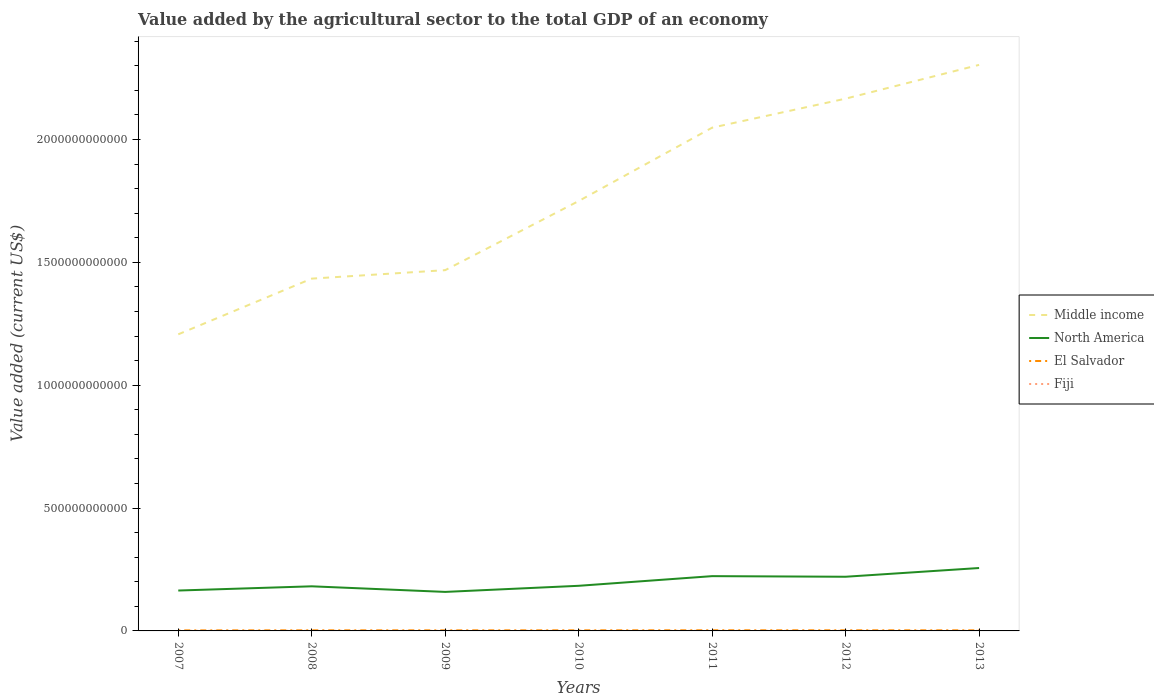Across all years, what is the maximum value added by the agricultural sector to the total GDP in North America?
Your answer should be compact. 1.59e+11. What is the total value added by the agricultural sector to the total GDP in Middle income in the graph?
Your answer should be compact. -8.70e+11. What is the difference between the highest and the second highest value added by the agricultural sector to the total GDP in Fiji?
Give a very brief answer. 1.34e+08. What is the difference between the highest and the lowest value added by the agricultural sector to the total GDP in North America?
Offer a terse response. 3. What is the difference between two consecutive major ticks on the Y-axis?
Provide a short and direct response. 5.00e+11. Are the values on the major ticks of Y-axis written in scientific E-notation?
Make the answer very short. No. Does the graph contain grids?
Give a very brief answer. No. Where does the legend appear in the graph?
Make the answer very short. Center right. How many legend labels are there?
Keep it short and to the point. 4. What is the title of the graph?
Provide a short and direct response. Value added by the agricultural sector to the total GDP of an economy. What is the label or title of the X-axis?
Provide a short and direct response. Years. What is the label or title of the Y-axis?
Offer a very short reply. Value added (current US$). What is the Value added (current US$) in Middle income in 2007?
Provide a succinct answer. 1.21e+12. What is the Value added (current US$) in North America in 2007?
Your answer should be compact. 1.64e+11. What is the Value added (current US$) in El Salvador in 2007?
Your answer should be very brief. 2.19e+09. What is the Value added (current US$) of Fiji in 2007?
Keep it short and to the point. 4.01e+08. What is the Value added (current US$) in Middle income in 2008?
Give a very brief answer. 1.43e+12. What is the Value added (current US$) of North America in 2008?
Offer a very short reply. 1.82e+11. What is the Value added (current US$) in El Salvador in 2008?
Your response must be concise. 2.46e+09. What is the Value added (current US$) in Fiji in 2008?
Make the answer very short. 3.77e+08. What is the Value added (current US$) in Middle income in 2009?
Provide a succinct answer. 1.47e+12. What is the Value added (current US$) of North America in 2009?
Your answer should be compact. 1.59e+11. What is the Value added (current US$) in El Salvador in 2009?
Make the answer very short. 2.37e+09. What is the Value added (current US$) in Fiji in 2009?
Keep it short and to the point. 2.90e+08. What is the Value added (current US$) in Middle income in 2010?
Your answer should be compact. 1.75e+12. What is the Value added (current US$) of North America in 2010?
Give a very brief answer. 1.84e+11. What is the Value added (current US$) of El Salvador in 2010?
Your response must be concise. 2.48e+09. What is the Value added (current US$) in Fiji in 2010?
Keep it short and to the point. 2.95e+08. What is the Value added (current US$) in Middle income in 2011?
Give a very brief answer. 2.05e+12. What is the Value added (current US$) in North America in 2011?
Offer a very short reply. 2.23e+11. What is the Value added (current US$) of El Salvador in 2011?
Provide a succinct answer. 2.65e+09. What is the Value added (current US$) in Fiji in 2011?
Give a very brief answer. 3.48e+08. What is the Value added (current US$) of Middle income in 2012?
Give a very brief answer. 2.17e+12. What is the Value added (current US$) in North America in 2012?
Your response must be concise. 2.21e+11. What is the Value added (current US$) of El Salvador in 2012?
Offer a terse response. 2.60e+09. What is the Value added (current US$) in Fiji in 2012?
Ensure brevity in your answer.  3.84e+08. What is the Value added (current US$) of Middle income in 2013?
Offer a terse response. 2.30e+12. What is the Value added (current US$) of North America in 2013?
Provide a short and direct response. 2.56e+11. What is the Value added (current US$) of El Salvador in 2013?
Keep it short and to the point. 2.45e+09. What is the Value added (current US$) of Fiji in 2013?
Make the answer very short. 4.24e+08. Across all years, what is the maximum Value added (current US$) in Middle income?
Provide a succinct answer. 2.30e+12. Across all years, what is the maximum Value added (current US$) of North America?
Offer a very short reply. 2.56e+11. Across all years, what is the maximum Value added (current US$) in El Salvador?
Offer a very short reply. 2.65e+09. Across all years, what is the maximum Value added (current US$) of Fiji?
Offer a terse response. 4.24e+08. Across all years, what is the minimum Value added (current US$) of Middle income?
Provide a short and direct response. 1.21e+12. Across all years, what is the minimum Value added (current US$) of North America?
Offer a very short reply. 1.59e+11. Across all years, what is the minimum Value added (current US$) in El Salvador?
Your answer should be very brief. 2.19e+09. Across all years, what is the minimum Value added (current US$) in Fiji?
Your response must be concise. 2.90e+08. What is the total Value added (current US$) in Middle income in the graph?
Your answer should be very brief. 1.24e+13. What is the total Value added (current US$) of North America in the graph?
Provide a succinct answer. 1.39e+12. What is the total Value added (current US$) of El Salvador in the graph?
Make the answer very short. 1.72e+1. What is the total Value added (current US$) of Fiji in the graph?
Your answer should be very brief. 2.52e+09. What is the difference between the Value added (current US$) in Middle income in 2007 and that in 2008?
Provide a succinct answer. -2.27e+11. What is the difference between the Value added (current US$) of North America in 2007 and that in 2008?
Provide a short and direct response. -1.72e+1. What is the difference between the Value added (current US$) in El Salvador in 2007 and that in 2008?
Ensure brevity in your answer.  -2.79e+08. What is the difference between the Value added (current US$) in Fiji in 2007 and that in 2008?
Offer a very short reply. 2.45e+07. What is the difference between the Value added (current US$) in Middle income in 2007 and that in 2009?
Keep it short and to the point. -2.61e+11. What is the difference between the Value added (current US$) of North America in 2007 and that in 2009?
Offer a terse response. 5.62e+09. What is the difference between the Value added (current US$) of El Salvador in 2007 and that in 2009?
Keep it short and to the point. -1.82e+08. What is the difference between the Value added (current US$) of Fiji in 2007 and that in 2009?
Provide a short and direct response. 1.12e+08. What is the difference between the Value added (current US$) of Middle income in 2007 and that in 2010?
Your answer should be very brief. -5.43e+11. What is the difference between the Value added (current US$) in North America in 2007 and that in 2010?
Ensure brevity in your answer.  -1.93e+1. What is the difference between the Value added (current US$) of El Salvador in 2007 and that in 2010?
Your response must be concise. -2.92e+08. What is the difference between the Value added (current US$) in Fiji in 2007 and that in 2010?
Offer a very short reply. 1.07e+08. What is the difference between the Value added (current US$) in Middle income in 2007 and that in 2011?
Provide a succinct answer. -8.41e+11. What is the difference between the Value added (current US$) of North America in 2007 and that in 2011?
Give a very brief answer. -5.85e+1. What is the difference between the Value added (current US$) of El Salvador in 2007 and that in 2011?
Make the answer very short. -4.66e+08. What is the difference between the Value added (current US$) in Fiji in 2007 and that in 2011?
Offer a very short reply. 5.35e+07. What is the difference between the Value added (current US$) in Middle income in 2007 and that in 2012?
Provide a short and direct response. -9.59e+11. What is the difference between the Value added (current US$) in North America in 2007 and that in 2012?
Keep it short and to the point. -5.61e+1. What is the difference between the Value added (current US$) of El Salvador in 2007 and that in 2012?
Make the answer very short. -4.12e+08. What is the difference between the Value added (current US$) in Fiji in 2007 and that in 2012?
Ensure brevity in your answer.  1.71e+07. What is the difference between the Value added (current US$) in Middle income in 2007 and that in 2013?
Offer a very short reply. -1.10e+12. What is the difference between the Value added (current US$) of North America in 2007 and that in 2013?
Your response must be concise. -9.17e+1. What is the difference between the Value added (current US$) of El Salvador in 2007 and that in 2013?
Your response must be concise. -2.63e+08. What is the difference between the Value added (current US$) in Fiji in 2007 and that in 2013?
Ensure brevity in your answer.  -2.23e+07. What is the difference between the Value added (current US$) in Middle income in 2008 and that in 2009?
Provide a short and direct response. -3.44e+1. What is the difference between the Value added (current US$) of North America in 2008 and that in 2009?
Ensure brevity in your answer.  2.28e+1. What is the difference between the Value added (current US$) of El Salvador in 2008 and that in 2009?
Your response must be concise. 9.73e+07. What is the difference between the Value added (current US$) in Fiji in 2008 and that in 2009?
Ensure brevity in your answer.  8.73e+07. What is the difference between the Value added (current US$) in Middle income in 2008 and that in 2010?
Provide a short and direct response. -3.16e+11. What is the difference between the Value added (current US$) of North America in 2008 and that in 2010?
Provide a succinct answer. -2.08e+09. What is the difference between the Value added (current US$) of El Salvador in 2008 and that in 2010?
Give a very brief answer. -1.29e+07. What is the difference between the Value added (current US$) in Fiji in 2008 and that in 2010?
Provide a succinct answer. 8.23e+07. What is the difference between the Value added (current US$) of Middle income in 2008 and that in 2011?
Give a very brief answer. -6.14e+11. What is the difference between the Value added (current US$) in North America in 2008 and that in 2011?
Your answer should be compact. -4.14e+1. What is the difference between the Value added (current US$) in El Salvador in 2008 and that in 2011?
Offer a terse response. -1.86e+08. What is the difference between the Value added (current US$) in Fiji in 2008 and that in 2011?
Offer a very short reply. 2.90e+07. What is the difference between the Value added (current US$) of Middle income in 2008 and that in 2012?
Keep it short and to the point. -7.32e+11. What is the difference between the Value added (current US$) in North America in 2008 and that in 2012?
Your response must be concise. -3.89e+1. What is the difference between the Value added (current US$) of El Salvador in 2008 and that in 2012?
Ensure brevity in your answer.  -1.32e+08. What is the difference between the Value added (current US$) of Fiji in 2008 and that in 2012?
Give a very brief answer. -7.43e+06. What is the difference between the Value added (current US$) of Middle income in 2008 and that in 2013?
Keep it short and to the point. -8.70e+11. What is the difference between the Value added (current US$) of North America in 2008 and that in 2013?
Keep it short and to the point. -7.45e+1. What is the difference between the Value added (current US$) of El Salvador in 2008 and that in 2013?
Ensure brevity in your answer.  1.62e+07. What is the difference between the Value added (current US$) in Fiji in 2008 and that in 2013?
Give a very brief answer. -4.69e+07. What is the difference between the Value added (current US$) of Middle income in 2009 and that in 2010?
Keep it short and to the point. -2.81e+11. What is the difference between the Value added (current US$) in North America in 2009 and that in 2010?
Offer a very short reply. -2.49e+1. What is the difference between the Value added (current US$) in El Salvador in 2009 and that in 2010?
Provide a short and direct response. -1.10e+08. What is the difference between the Value added (current US$) of Fiji in 2009 and that in 2010?
Offer a very short reply. -5.04e+06. What is the difference between the Value added (current US$) in Middle income in 2009 and that in 2011?
Make the answer very short. -5.80e+11. What is the difference between the Value added (current US$) in North America in 2009 and that in 2011?
Offer a terse response. -6.42e+1. What is the difference between the Value added (current US$) in El Salvador in 2009 and that in 2011?
Offer a very short reply. -2.84e+08. What is the difference between the Value added (current US$) of Fiji in 2009 and that in 2011?
Provide a succinct answer. -5.83e+07. What is the difference between the Value added (current US$) of Middle income in 2009 and that in 2012?
Offer a terse response. -6.98e+11. What is the difference between the Value added (current US$) in North America in 2009 and that in 2012?
Keep it short and to the point. -6.17e+1. What is the difference between the Value added (current US$) in El Salvador in 2009 and that in 2012?
Ensure brevity in your answer.  -2.30e+08. What is the difference between the Value added (current US$) of Fiji in 2009 and that in 2012?
Keep it short and to the point. -9.47e+07. What is the difference between the Value added (current US$) in Middle income in 2009 and that in 2013?
Your answer should be very brief. -8.36e+11. What is the difference between the Value added (current US$) of North America in 2009 and that in 2013?
Give a very brief answer. -9.73e+1. What is the difference between the Value added (current US$) in El Salvador in 2009 and that in 2013?
Make the answer very short. -8.11e+07. What is the difference between the Value added (current US$) in Fiji in 2009 and that in 2013?
Your answer should be compact. -1.34e+08. What is the difference between the Value added (current US$) in Middle income in 2010 and that in 2011?
Provide a short and direct response. -2.99e+11. What is the difference between the Value added (current US$) of North America in 2010 and that in 2011?
Ensure brevity in your answer.  -3.93e+1. What is the difference between the Value added (current US$) of El Salvador in 2010 and that in 2011?
Give a very brief answer. -1.74e+08. What is the difference between the Value added (current US$) of Fiji in 2010 and that in 2011?
Provide a short and direct response. -5.33e+07. What is the difference between the Value added (current US$) of Middle income in 2010 and that in 2012?
Ensure brevity in your answer.  -4.17e+11. What is the difference between the Value added (current US$) of North America in 2010 and that in 2012?
Your answer should be very brief. -3.69e+1. What is the difference between the Value added (current US$) in El Salvador in 2010 and that in 2012?
Give a very brief answer. -1.20e+08. What is the difference between the Value added (current US$) of Fiji in 2010 and that in 2012?
Offer a terse response. -8.97e+07. What is the difference between the Value added (current US$) of Middle income in 2010 and that in 2013?
Keep it short and to the point. -5.54e+11. What is the difference between the Value added (current US$) in North America in 2010 and that in 2013?
Ensure brevity in your answer.  -7.24e+1. What is the difference between the Value added (current US$) in El Salvador in 2010 and that in 2013?
Keep it short and to the point. 2.91e+07. What is the difference between the Value added (current US$) in Fiji in 2010 and that in 2013?
Your answer should be very brief. -1.29e+08. What is the difference between the Value added (current US$) in Middle income in 2011 and that in 2012?
Keep it short and to the point. -1.18e+11. What is the difference between the Value added (current US$) of North America in 2011 and that in 2012?
Provide a succinct answer. 2.44e+09. What is the difference between the Value added (current US$) in El Salvador in 2011 and that in 2012?
Give a very brief answer. 5.40e+07. What is the difference between the Value added (current US$) in Fiji in 2011 and that in 2012?
Give a very brief answer. -3.64e+07. What is the difference between the Value added (current US$) of Middle income in 2011 and that in 2013?
Offer a very short reply. -2.56e+11. What is the difference between the Value added (current US$) in North America in 2011 and that in 2013?
Provide a short and direct response. -3.31e+1. What is the difference between the Value added (current US$) in El Salvador in 2011 and that in 2013?
Provide a succinct answer. 2.03e+08. What is the difference between the Value added (current US$) of Fiji in 2011 and that in 2013?
Make the answer very short. -7.58e+07. What is the difference between the Value added (current US$) of Middle income in 2012 and that in 2013?
Your answer should be compact. -1.37e+11. What is the difference between the Value added (current US$) in North America in 2012 and that in 2013?
Ensure brevity in your answer.  -3.55e+1. What is the difference between the Value added (current US$) of El Salvador in 2012 and that in 2013?
Offer a very short reply. 1.49e+08. What is the difference between the Value added (current US$) in Fiji in 2012 and that in 2013?
Offer a very short reply. -3.94e+07. What is the difference between the Value added (current US$) of Middle income in 2007 and the Value added (current US$) of North America in 2008?
Your answer should be compact. 1.03e+12. What is the difference between the Value added (current US$) in Middle income in 2007 and the Value added (current US$) in El Salvador in 2008?
Provide a short and direct response. 1.20e+12. What is the difference between the Value added (current US$) in Middle income in 2007 and the Value added (current US$) in Fiji in 2008?
Your answer should be compact. 1.21e+12. What is the difference between the Value added (current US$) in North America in 2007 and the Value added (current US$) in El Salvador in 2008?
Provide a short and direct response. 1.62e+11. What is the difference between the Value added (current US$) of North America in 2007 and the Value added (current US$) of Fiji in 2008?
Offer a terse response. 1.64e+11. What is the difference between the Value added (current US$) of El Salvador in 2007 and the Value added (current US$) of Fiji in 2008?
Keep it short and to the point. 1.81e+09. What is the difference between the Value added (current US$) of Middle income in 2007 and the Value added (current US$) of North America in 2009?
Make the answer very short. 1.05e+12. What is the difference between the Value added (current US$) of Middle income in 2007 and the Value added (current US$) of El Salvador in 2009?
Provide a short and direct response. 1.20e+12. What is the difference between the Value added (current US$) of Middle income in 2007 and the Value added (current US$) of Fiji in 2009?
Provide a succinct answer. 1.21e+12. What is the difference between the Value added (current US$) of North America in 2007 and the Value added (current US$) of El Salvador in 2009?
Your response must be concise. 1.62e+11. What is the difference between the Value added (current US$) in North America in 2007 and the Value added (current US$) in Fiji in 2009?
Your answer should be compact. 1.64e+11. What is the difference between the Value added (current US$) of El Salvador in 2007 and the Value added (current US$) of Fiji in 2009?
Make the answer very short. 1.90e+09. What is the difference between the Value added (current US$) of Middle income in 2007 and the Value added (current US$) of North America in 2010?
Give a very brief answer. 1.02e+12. What is the difference between the Value added (current US$) in Middle income in 2007 and the Value added (current US$) in El Salvador in 2010?
Your answer should be very brief. 1.20e+12. What is the difference between the Value added (current US$) in Middle income in 2007 and the Value added (current US$) in Fiji in 2010?
Provide a short and direct response. 1.21e+12. What is the difference between the Value added (current US$) of North America in 2007 and the Value added (current US$) of El Salvador in 2010?
Give a very brief answer. 1.62e+11. What is the difference between the Value added (current US$) of North America in 2007 and the Value added (current US$) of Fiji in 2010?
Offer a very short reply. 1.64e+11. What is the difference between the Value added (current US$) of El Salvador in 2007 and the Value added (current US$) of Fiji in 2010?
Offer a terse response. 1.89e+09. What is the difference between the Value added (current US$) of Middle income in 2007 and the Value added (current US$) of North America in 2011?
Your answer should be compact. 9.84e+11. What is the difference between the Value added (current US$) of Middle income in 2007 and the Value added (current US$) of El Salvador in 2011?
Keep it short and to the point. 1.20e+12. What is the difference between the Value added (current US$) of Middle income in 2007 and the Value added (current US$) of Fiji in 2011?
Make the answer very short. 1.21e+12. What is the difference between the Value added (current US$) in North America in 2007 and the Value added (current US$) in El Salvador in 2011?
Your answer should be compact. 1.62e+11. What is the difference between the Value added (current US$) of North America in 2007 and the Value added (current US$) of Fiji in 2011?
Keep it short and to the point. 1.64e+11. What is the difference between the Value added (current US$) in El Salvador in 2007 and the Value added (current US$) in Fiji in 2011?
Offer a terse response. 1.84e+09. What is the difference between the Value added (current US$) of Middle income in 2007 and the Value added (current US$) of North America in 2012?
Your answer should be very brief. 9.87e+11. What is the difference between the Value added (current US$) in Middle income in 2007 and the Value added (current US$) in El Salvador in 2012?
Give a very brief answer. 1.20e+12. What is the difference between the Value added (current US$) in Middle income in 2007 and the Value added (current US$) in Fiji in 2012?
Make the answer very short. 1.21e+12. What is the difference between the Value added (current US$) in North America in 2007 and the Value added (current US$) in El Salvador in 2012?
Offer a very short reply. 1.62e+11. What is the difference between the Value added (current US$) in North America in 2007 and the Value added (current US$) in Fiji in 2012?
Offer a very short reply. 1.64e+11. What is the difference between the Value added (current US$) of El Salvador in 2007 and the Value added (current US$) of Fiji in 2012?
Give a very brief answer. 1.80e+09. What is the difference between the Value added (current US$) in Middle income in 2007 and the Value added (current US$) in North America in 2013?
Offer a terse response. 9.51e+11. What is the difference between the Value added (current US$) in Middle income in 2007 and the Value added (current US$) in El Salvador in 2013?
Offer a terse response. 1.20e+12. What is the difference between the Value added (current US$) of Middle income in 2007 and the Value added (current US$) of Fiji in 2013?
Your answer should be compact. 1.21e+12. What is the difference between the Value added (current US$) of North America in 2007 and the Value added (current US$) of El Salvador in 2013?
Offer a terse response. 1.62e+11. What is the difference between the Value added (current US$) of North America in 2007 and the Value added (current US$) of Fiji in 2013?
Provide a short and direct response. 1.64e+11. What is the difference between the Value added (current US$) of El Salvador in 2007 and the Value added (current US$) of Fiji in 2013?
Offer a terse response. 1.76e+09. What is the difference between the Value added (current US$) in Middle income in 2008 and the Value added (current US$) in North America in 2009?
Offer a very short reply. 1.28e+12. What is the difference between the Value added (current US$) of Middle income in 2008 and the Value added (current US$) of El Salvador in 2009?
Provide a short and direct response. 1.43e+12. What is the difference between the Value added (current US$) of Middle income in 2008 and the Value added (current US$) of Fiji in 2009?
Offer a terse response. 1.43e+12. What is the difference between the Value added (current US$) of North America in 2008 and the Value added (current US$) of El Salvador in 2009?
Offer a very short reply. 1.79e+11. What is the difference between the Value added (current US$) in North America in 2008 and the Value added (current US$) in Fiji in 2009?
Your answer should be compact. 1.81e+11. What is the difference between the Value added (current US$) of El Salvador in 2008 and the Value added (current US$) of Fiji in 2009?
Give a very brief answer. 2.18e+09. What is the difference between the Value added (current US$) in Middle income in 2008 and the Value added (current US$) in North America in 2010?
Provide a short and direct response. 1.25e+12. What is the difference between the Value added (current US$) in Middle income in 2008 and the Value added (current US$) in El Salvador in 2010?
Give a very brief answer. 1.43e+12. What is the difference between the Value added (current US$) of Middle income in 2008 and the Value added (current US$) of Fiji in 2010?
Offer a terse response. 1.43e+12. What is the difference between the Value added (current US$) of North America in 2008 and the Value added (current US$) of El Salvador in 2010?
Your response must be concise. 1.79e+11. What is the difference between the Value added (current US$) of North America in 2008 and the Value added (current US$) of Fiji in 2010?
Provide a succinct answer. 1.81e+11. What is the difference between the Value added (current US$) in El Salvador in 2008 and the Value added (current US$) in Fiji in 2010?
Your answer should be compact. 2.17e+09. What is the difference between the Value added (current US$) in Middle income in 2008 and the Value added (current US$) in North America in 2011?
Ensure brevity in your answer.  1.21e+12. What is the difference between the Value added (current US$) in Middle income in 2008 and the Value added (current US$) in El Salvador in 2011?
Make the answer very short. 1.43e+12. What is the difference between the Value added (current US$) in Middle income in 2008 and the Value added (current US$) in Fiji in 2011?
Your answer should be compact. 1.43e+12. What is the difference between the Value added (current US$) in North America in 2008 and the Value added (current US$) in El Salvador in 2011?
Keep it short and to the point. 1.79e+11. What is the difference between the Value added (current US$) in North America in 2008 and the Value added (current US$) in Fiji in 2011?
Provide a succinct answer. 1.81e+11. What is the difference between the Value added (current US$) of El Salvador in 2008 and the Value added (current US$) of Fiji in 2011?
Give a very brief answer. 2.12e+09. What is the difference between the Value added (current US$) of Middle income in 2008 and the Value added (current US$) of North America in 2012?
Ensure brevity in your answer.  1.21e+12. What is the difference between the Value added (current US$) of Middle income in 2008 and the Value added (current US$) of El Salvador in 2012?
Provide a succinct answer. 1.43e+12. What is the difference between the Value added (current US$) of Middle income in 2008 and the Value added (current US$) of Fiji in 2012?
Provide a succinct answer. 1.43e+12. What is the difference between the Value added (current US$) in North America in 2008 and the Value added (current US$) in El Salvador in 2012?
Give a very brief answer. 1.79e+11. What is the difference between the Value added (current US$) in North America in 2008 and the Value added (current US$) in Fiji in 2012?
Offer a terse response. 1.81e+11. What is the difference between the Value added (current US$) in El Salvador in 2008 and the Value added (current US$) in Fiji in 2012?
Keep it short and to the point. 2.08e+09. What is the difference between the Value added (current US$) in Middle income in 2008 and the Value added (current US$) in North America in 2013?
Offer a terse response. 1.18e+12. What is the difference between the Value added (current US$) in Middle income in 2008 and the Value added (current US$) in El Salvador in 2013?
Provide a succinct answer. 1.43e+12. What is the difference between the Value added (current US$) in Middle income in 2008 and the Value added (current US$) in Fiji in 2013?
Provide a succinct answer. 1.43e+12. What is the difference between the Value added (current US$) in North America in 2008 and the Value added (current US$) in El Salvador in 2013?
Your answer should be very brief. 1.79e+11. What is the difference between the Value added (current US$) of North America in 2008 and the Value added (current US$) of Fiji in 2013?
Your answer should be very brief. 1.81e+11. What is the difference between the Value added (current US$) of El Salvador in 2008 and the Value added (current US$) of Fiji in 2013?
Keep it short and to the point. 2.04e+09. What is the difference between the Value added (current US$) of Middle income in 2009 and the Value added (current US$) of North America in 2010?
Provide a succinct answer. 1.28e+12. What is the difference between the Value added (current US$) of Middle income in 2009 and the Value added (current US$) of El Salvador in 2010?
Provide a succinct answer. 1.47e+12. What is the difference between the Value added (current US$) of Middle income in 2009 and the Value added (current US$) of Fiji in 2010?
Provide a succinct answer. 1.47e+12. What is the difference between the Value added (current US$) of North America in 2009 and the Value added (current US$) of El Salvador in 2010?
Offer a terse response. 1.56e+11. What is the difference between the Value added (current US$) of North America in 2009 and the Value added (current US$) of Fiji in 2010?
Ensure brevity in your answer.  1.58e+11. What is the difference between the Value added (current US$) in El Salvador in 2009 and the Value added (current US$) in Fiji in 2010?
Offer a terse response. 2.07e+09. What is the difference between the Value added (current US$) of Middle income in 2009 and the Value added (current US$) of North America in 2011?
Give a very brief answer. 1.25e+12. What is the difference between the Value added (current US$) in Middle income in 2009 and the Value added (current US$) in El Salvador in 2011?
Provide a succinct answer. 1.47e+12. What is the difference between the Value added (current US$) in Middle income in 2009 and the Value added (current US$) in Fiji in 2011?
Your response must be concise. 1.47e+12. What is the difference between the Value added (current US$) in North America in 2009 and the Value added (current US$) in El Salvador in 2011?
Make the answer very short. 1.56e+11. What is the difference between the Value added (current US$) in North America in 2009 and the Value added (current US$) in Fiji in 2011?
Your response must be concise. 1.58e+11. What is the difference between the Value added (current US$) of El Salvador in 2009 and the Value added (current US$) of Fiji in 2011?
Offer a terse response. 2.02e+09. What is the difference between the Value added (current US$) in Middle income in 2009 and the Value added (current US$) in North America in 2012?
Offer a terse response. 1.25e+12. What is the difference between the Value added (current US$) in Middle income in 2009 and the Value added (current US$) in El Salvador in 2012?
Make the answer very short. 1.47e+12. What is the difference between the Value added (current US$) in Middle income in 2009 and the Value added (current US$) in Fiji in 2012?
Offer a terse response. 1.47e+12. What is the difference between the Value added (current US$) in North America in 2009 and the Value added (current US$) in El Salvador in 2012?
Provide a short and direct response. 1.56e+11. What is the difference between the Value added (current US$) in North America in 2009 and the Value added (current US$) in Fiji in 2012?
Offer a very short reply. 1.58e+11. What is the difference between the Value added (current US$) of El Salvador in 2009 and the Value added (current US$) of Fiji in 2012?
Ensure brevity in your answer.  1.98e+09. What is the difference between the Value added (current US$) in Middle income in 2009 and the Value added (current US$) in North America in 2013?
Your answer should be very brief. 1.21e+12. What is the difference between the Value added (current US$) in Middle income in 2009 and the Value added (current US$) in El Salvador in 2013?
Your answer should be very brief. 1.47e+12. What is the difference between the Value added (current US$) in Middle income in 2009 and the Value added (current US$) in Fiji in 2013?
Offer a terse response. 1.47e+12. What is the difference between the Value added (current US$) in North America in 2009 and the Value added (current US$) in El Salvador in 2013?
Offer a terse response. 1.56e+11. What is the difference between the Value added (current US$) of North America in 2009 and the Value added (current US$) of Fiji in 2013?
Provide a short and direct response. 1.58e+11. What is the difference between the Value added (current US$) of El Salvador in 2009 and the Value added (current US$) of Fiji in 2013?
Offer a very short reply. 1.94e+09. What is the difference between the Value added (current US$) of Middle income in 2010 and the Value added (current US$) of North America in 2011?
Provide a short and direct response. 1.53e+12. What is the difference between the Value added (current US$) of Middle income in 2010 and the Value added (current US$) of El Salvador in 2011?
Offer a very short reply. 1.75e+12. What is the difference between the Value added (current US$) in Middle income in 2010 and the Value added (current US$) in Fiji in 2011?
Your response must be concise. 1.75e+12. What is the difference between the Value added (current US$) of North America in 2010 and the Value added (current US$) of El Salvador in 2011?
Give a very brief answer. 1.81e+11. What is the difference between the Value added (current US$) of North America in 2010 and the Value added (current US$) of Fiji in 2011?
Offer a very short reply. 1.83e+11. What is the difference between the Value added (current US$) in El Salvador in 2010 and the Value added (current US$) in Fiji in 2011?
Give a very brief answer. 2.13e+09. What is the difference between the Value added (current US$) of Middle income in 2010 and the Value added (current US$) of North America in 2012?
Provide a short and direct response. 1.53e+12. What is the difference between the Value added (current US$) in Middle income in 2010 and the Value added (current US$) in El Salvador in 2012?
Your response must be concise. 1.75e+12. What is the difference between the Value added (current US$) of Middle income in 2010 and the Value added (current US$) of Fiji in 2012?
Offer a terse response. 1.75e+12. What is the difference between the Value added (current US$) in North America in 2010 and the Value added (current US$) in El Salvador in 2012?
Give a very brief answer. 1.81e+11. What is the difference between the Value added (current US$) of North America in 2010 and the Value added (current US$) of Fiji in 2012?
Your answer should be very brief. 1.83e+11. What is the difference between the Value added (current US$) in El Salvador in 2010 and the Value added (current US$) in Fiji in 2012?
Make the answer very short. 2.09e+09. What is the difference between the Value added (current US$) of Middle income in 2010 and the Value added (current US$) of North America in 2013?
Give a very brief answer. 1.49e+12. What is the difference between the Value added (current US$) of Middle income in 2010 and the Value added (current US$) of El Salvador in 2013?
Your response must be concise. 1.75e+12. What is the difference between the Value added (current US$) in Middle income in 2010 and the Value added (current US$) in Fiji in 2013?
Offer a terse response. 1.75e+12. What is the difference between the Value added (current US$) in North America in 2010 and the Value added (current US$) in El Salvador in 2013?
Ensure brevity in your answer.  1.81e+11. What is the difference between the Value added (current US$) in North America in 2010 and the Value added (current US$) in Fiji in 2013?
Your response must be concise. 1.83e+11. What is the difference between the Value added (current US$) in El Salvador in 2010 and the Value added (current US$) in Fiji in 2013?
Your answer should be compact. 2.05e+09. What is the difference between the Value added (current US$) of Middle income in 2011 and the Value added (current US$) of North America in 2012?
Offer a very short reply. 1.83e+12. What is the difference between the Value added (current US$) in Middle income in 2011 and the Value added (current US$) in El Salvador in 2012?
Provide a short and direct response. 2.05e+12. What is the difference between the Value added (current US$) of Middle income in 2011 and the Value added (current US$) of Fiji in 2012?
Provide a succinct answer. 2.05e+12. What is the difference between the Value added (current US$) of North America in 2011 and the Value added (current US$) of El Salvador in 2012?
Provide a short and direct response. 2.20e+11. What is the difference between the Value added (current US$) of North America in 2011 and the Value added (current US$) of Fiji in 2012?
Keep it short and to the point. 2.23e+11. What is the difference between the Value added (current US$) of El Salvador in 2011 and the Value added (current US$) of Fiji in 2012?
Your answer should be very brief. 2.27e+09. What is the difference between the Value added (current US$) of Middle income in 2011 and the Value added (current US$) of North America in 2013?
Your answer should be compact. 1.79e+12. What is the difference between the Value added (current US$) in Middle income in 2011 and the Value added (current US$) in El Salvador in 2013?
Your response must be concise. 2.05e+12. What is the difference between the Value added (current US$) of Middle income in 2011 and the Value added (current US$) of Fiji in 2013?
Make the answer very short. 2.05e+12. What is the difference between the Value added (current US$) of North America in 2011 and the Value added (current US$) of El Salvador in 2013?
Your answer should be very brief. 2.20e+11. What is the difference between the Value added (current US$) in North America in 2011 and the Value added (current US$) in Fiji in 2013?
Give a very brief answer. 2.23e+11. What is the difference between the Value added (current US$) of El Salvador in 2011 and the Value added (current US$) of Fiji in 2013?
Provide a short and direct response. 2.23e+09. What is the difference between the Value added (current US$) in Middle income in 2012 and the Value added (current US$) in North America in 2013?
Your answer should be compact. 1.91e+12. What is the difference between the Value added (current US$) of Middle income in 2012 and the Value added (current US$) of El Salvador in 2013?
Provide a succinct answer. 2.16e+12. What is the difference between the Value added (current US$) of Middle income in 2012 and the Value added (current US$) of Fiji in 2013?
Provide a succinct answer. 2.17e+12. What is the difference between the Value added (current US$) in North America in 2012 and the Value added (current US$) in El Salvador in 2013?
Provide a short and direct response. 2.18e+11. What is the difference between the Value added (current US$) of North America in 2012 and the Value added (current US$) of Fiji in 2013?
Ensure brevity in your answer.  2.20e+11. What is the difference between the Value added (current US$) in El Salvador in 2012 and the Value added (current US$) in Fiji in 2013?
Keep it short and to the point. 2.17e+09. What is the average Value added (current US$) in Middle income per year?
Give a very brief answer. 1.77e+12. What is the average Value added (current US$) of North America per year?
Your response must be concise. 1.98e+11. What is the average Value added (current US$) in El Salvador per year?
Your answer should be very brief. 2.46e+09. What is the average Value added (current US$) of Fiji per year?
Provide a succinct answer. 3.60e+08. In the year 2007, what is the difference between the Value added (current US$) in Middle income and Value added (current US$) in North America?
Keep it short and to the point. 1.04e+12. In the year 2007, what is the difference between the Value added (current US$) of Middle income and Value added (current US$) of El Salvador?
Offer a terse response. 1.20e+12. In the year 2007, what is the difference between the Value added (current US$) in Middle income and Value added (current US$) in Fiji?
Offer a very short reply. 1.21e+12. In the year 2007, what is the difference between the Value added (current US$) in North America and Value added (current US$) in El Salvador?
Your answer should be compact. 1.62e+11. In the year 2007, what is the difference between the Value added (current US$) of North America and Value added (current US$) of Fiji?
Provide a short and direct response. 1.64e+11. In the year 2007, what is the difference between the Value added (current US$) of El Salvador and Value added (current US$) of Fiji?
Keep it short and to the point. 1.78e+09. In the year 2008, what is the difference between the Value added (current US$) of Middle income and Value added (current US$) of North America?
Provide a succinct answer. 1.25e+12. In the year 2008, what is the difference between the Value added (current US$) of Middle income and Value added (current US$) of El Salvador?
Provide a succinct answer. 1.43e+12. In the year 2008, what is the difference between the Value added (current US$) in Middle income and Value added (current US$) in Fiji?
Keep it short and to the point. 1.43e+12. In the year 2008, what is the difference between the Value added (current US$) in North America and Value added (current US$) in El Salvador?
Your answer should be compact. 1.79e+11. In the year 2008, what is the difference between the Value added (current US$) in North America and Value added (current US$) in Fiji?
Your response must be concise. 1.81e+11. In the year 2008, what is the difference between the Value added (current US$) in El Salvador and Value added (current US$) in Fiji?
Provide a succinct answer. 2.09e+09. In the year 2009, what is the difference between the Value added (current US$) of Middle income and Value added (current US$) of North America?
Provide a succinct answer. 1.31e+12. In the year 2009, what is the difference between the Value added (current US$) of Middle income and Value added (current US$) of El Salvador?
Give a very brief answer. 1.47e+12. In the year 2009, what is the difference between the Value added (current US$) of Middle income and Value added (current US$) of Fiji?
Your response must be concise. 1.47e+12. In the year 2009, what is the difference between the Value added (current US$) of North America and Value added (current US$) of El Salvador?
Your answer should be compact. 1.56e+11. In the year 2009, what is the difference between the Value added (current US$) of North America and Value added (current US$) of Fiji?
Your answer should be compact. 1.58e+11. In the year 2009, what is the difference between the Value added (current US$) in El Salvador and Value added (current US$) in Fiji?
Provide a short and direct response. 2.08e+09. In the year 2010, what is the difference between the Value added (current US$) of Middle income and Value added (current US$) of North America?
Your response must be concise. 1.57e+12. In the year 2010, what is the difference between the Value added (current US$) of Middle income and Value added (current US$) of El Salvador?
Your answer should be compact. 1.75e+12. In the year 2010, what is the difference between the Value added (current US$) of Middle income and Value added (current US$) of Fiji?
Keep it short and to the point. 1.75e+12. In the year 2010, what is the difference between the Value added (current US$) in North America and Value added (current US$) in El Salvador?
Keep it short and to the point. 1.81e+11. In the year 2010, what is the difference between the Value added (current US$) of North America and Value added (current US$) of Fiji?
Give a very brief answer. 1.83e+11. In the year 2010, what is the difference between the Value added (current US$) of El Salvador and Value added (current US$) of Fiji?
Your answer should be very brief. 2.18e+09. In the year 2011, what is the difference between the Value added (current US$) in Middle income and Value added (current US$) in North America?
Ensure brevity in your answer.  1.83e+12. In the year 2011, what is the difference between the Value added (current US$) in Middle income and Value added (current US$) in El Salvador?
Keep it short and to the point. 2.05e+12. In the year 2011, what is the difference between the Value added (current US$) of Middle income and Value added (current US$) of Fiji?
Keep it short and to the point. 2.05e+12. In the year 2011, what is the difference between the Value added (current US$) of North America and Value added (current US$) of El Salvador?
Make the answer very short. 2.20e+11. In the year 2011, what is the difference between the Value added (current US$) in North America and Value added (current US$) in Fiji?
Provide a succinct answer. 2.23e+11. In the year 2011, what is the difference between the Value added (current US$) of El Salvador and Value added (current US$) of Fiji?
Provide a succinct answer. 2.30e+09. In the year 2012, what is the difference between the Value added (current US$) in Middle income and Value added (current US$) in North America?
Offer a very short reply. 1.95e+12. In the year 2012, what is the difference between the Value added (current US$) of Middle income and Value added (current US$) of El Salvador?
Provide a succinct answer. 2.16e+12. In the year 2012, what is the difference between the Value added (current US$) of Middle income and Value added (current US$) of Fiji?
Keep it short and to the point. 2.17e+12. In the year 2012, what is the difference between the Value added (current US$) of North America and Value added (current US$) of El Salvador?
Give a very brief answer. 2.18e+11. In the year 2012, what is the difference between the Value added (current US$) of North America and Value added (current US$) of Fiji?
Keep it short and to the point. 2.20e+11. In the year 2012, what is the difference between the Value added (current US$) in El Salvador and Value added (current US$) in Fiji?
Your answer should be very brief. 2.21e+09. In the year 2013, what is the difference between the Value added (current US$) of Middle income and Value added (current US$) of North America?
Your response must be concise. 2.05e+12. In the year 2013, what is the difference between the Value added (current US$) in Middle income and Value added (current US$) in El Salvador?
Make the answer very short. 2.30e+12. In the year 2013, what is the difference between the Value added (current US$) in Middle income and Value added (current US$) in Fiji?
Your answer should be compact. 2.30e+12. In the year 2013, what is the difference between the Value added (current US$) of North America and Value added (current US$) of El Salvador?
Offer a terse response. 2.54e+11. In the year 2013, what is the difference between the Value added (current US$) in North America and Value added (current US$) in Fiji?
Give a very brief answer. 2.56e+11. In the year 2013, what is the difference between the Value added (current US$) of El Salvador and Value added (current US$) of Fiji?
Offer a terse response. 2.03e+09. What is the ratio of the Value added (current US$) of Middle income in 2007 to that in 2008?
Keep it short and to the point. 0.84. What is the ratio of the Value added (current US$) of North America in 2007 to that in 2008?
Your answer should be compact. 0.91. What is the ratio of the Value added (current US$) of El Salvador in 2007 to that in 2008?
Offer a terse response. 0.89. What is the ratio of the Value added (current US$) of Fiji in 2007 to that in 2008?
Offer a very short reply. 1.07. What is the ratio of the Value added (current US$) of Middle income in 2007 to that in 2009?
Your response must be concise. 0.82. What is the ratio of the Value added (current US$) of North America in 2007 to that in 2009?
Your answer should be very brief. 1.04. What is the ratio of the Value added (current US$) of Fiji in 2007 to that in 2009?
Offer a very short reply. 1.39. What is the ratio of the Value added (current US$) in Middle income in 2007 to that in 2010?
Offer a terse response. 0.69. What is the ratio of the Value added (current US$) of North America in 2007 to that in 2010?
Ensure brevity in your answer.  0.9. What is the ratio of the Value added (current US$) of El Salvador in 2007 to that in 2010?
Your response must be concise. 0.88. What is the ratio of the Value added (current US$) of Fiji in 2007 to that in 2010?
Provide a short and direct response. 1.36. What is the ratio of the Value added (current US$) of Middle income in 2007 to that in 2011?
Give a very brief answer. 0.59. What is the ratio of the Value added (current US$) in North America in 2007 to that in 2011?
Keep it short and to the point. 0.74. What is the ratio of the Value added (current US$) of El Salvador in 2007 to that in 2011?
Provide a succinct answer. 0.82. What is the ratio of the Value added (current US$) in Fiji in 2007 to that in 2011?
Keep it short and to the point. 1.15. What is the ratio of the Value added (current US$) of Middle income in 2007 to that in 2012?
Offer a terse response. 0.56. What is the ratio of the Value added (current US$) of North America in 2007 to that in 2012?
Provide a short and direct response. 0.75. What is the ratio of the Value added (current US$) of El Salvador in 2007 to that in 2012?
Your response must be concise. 0.84. What is the ratio of the Value added (current US$) of Fiji in 2007 to that in 2012?
Your response must be concise. 1.04. What is the ratio of the Value added (current US$) of Middle income in 2007 to that in 2013?
Offer a terse response. 0.52. What is the ratio of the Value added (current US$) in North America in 2007 to that in 2013?
Provide a short and direct response. 0.64. What is the ratio of the Value added (current US$) of El Salvador in 2007 to that in 2013?
Provide a succinct answer. 0.89. What is the ratio of the Value added (current US$) in Fiji in 2007 to that in 2013?
Provide a succinct answer. 0.95. What is the ratio of the Value added (current US$) in Middle income in 2008 to that in 2009?
Your response must be concise. 0.98. What is the ratio of the Value added (current US$) of North America in 2008 to that in 2009?
Give a very brief answer. 1.14. What is the ratio of the Value added (current US$) of El Salvador in 2008 to that in 2009?
Give a very brief answer. 1.04. What is the ratio of the Value added (current US$) in Fiji in 2008 to that in 2009?
Offer a very short reply. 1.3. What is the ratio of the Value added (current US$) of Middle income in 2008 to that in 2010?
Make the answer very short. 0.82. What is the ratio of the Value added (current US$) in North America in 2008 to that in 2010?
Ensure brevity in your answer.  0.99. What is the ratio of the Value added (current US$) of Fiji in 2008 to that in 2010?
Make the answer very short. 1.28. What is the ratio of the Value added (current US$) in North America in 2008 to that in 2011?
Your answer should be compact. 0.81. What is the ratio of the Value added (current US$) in El Salvador in 2008 to that in 2011?
Your answer should be compact. 0.93. What is the ratio of the Value added (current US$) in Fiji in 2008 to that in 2011?
Your answer should be compact. 1.08. What is the ratio of the Value added (current US$) of Middle income in 2008 to that in 2012?
Provide a succinct answer. 0.66. What is the ratio of the Value added (current US$) of North America in 2008 to that in 2012?
Your answer should be very brief. 0.82. What is the ratio of the Value added (current US$) in El Salvador in 2008 to that in 2012?
Provide a succinct answer. 0.95. What is the ratio of the Value added (current US$) of Fiji in 2008 to that in 2012?
Offer a terse response. 0.98. What is the ratio of the Value added (current US$) in Middle income in 2008 to that in 2013?
Offer a very short reply. 0.62. What is the ratio of the Value added (current US$) of North America in 2008 to that in 2013?
Ensure brevity in your answer.  0.71. What is the ratio of the Value added (current US$) in El Salvador in 2008 to that in 2013?
Keep it short and to the point. 1.01. What is the ratio of the Value added (current US$) in Fiji in 2008 to that in 2013?
Your response must be concise. 0.89. What is the ratio of the Value added (current US$) in Middle income in 2009 to that in 2010?
Your answer should be compact. 0.84. What is the ratio of the Value added (current US$) in North America in 2009 to that in 2010?
Provide a succinct answer. 0.86. What is the ratio of the Value added (current US$) in El Salvador in 2009 to that in 2010?
Ensure brevity in your answer.  0.96. What is the ratio of the Value added (current US$) of Fiji in 2009 to that in 2010?
Your response must be concise. 0.98. What is the ratio of the Value added (current US$) of Middle income in 2009 to that in 2011?
Provide a succinct answer. 0.72. What is the ratio of the Value added (current US$) in North America in 2009 to that in 2011?
Make the answer very short. 0.71. What is the ratio of the Value added (current US$) of El Salvador in 2009 to that in 2011?
Make the answer very short. 0.89. What is the ratio of the Value added (current US$) of Fiji in 2009 to that in 2011?
Your response must be concise. 0.83. What is the ratio of the Value added (current US$) of Middle income in 2009 to that in 2012?
Ensure brevity in your answer.  0.68. What is the ratio of the Value added (current US$) in North America in 2009 to that in 2012?
Make the answer very short. 0.72. What is the ratio of the Value added (current US$) of El Salvador in 2009 to that in 2012?
Give a very brief answer. 0.91. What is the ratio of the Value added (current US$) in Fiji in 2009 to that in 2012?
Offer a very short reply. 0.75. What is the ratio of the Value added (current US$) of Middle income in 2009 to that in 2013?
Provide a succinct answer. 0.64. What is the ratio of the Value added (current US$) in North America in 2009 to that in 2013?
Your answer should be very brief. 0.62. What is the ratio of the Value added (current US$) in El Salvador in 2009 to that in 2013?
Offer a very short reply. 0.97. What is the ratio of the Value added (current US$) in Fiji in 2009 to that in 2013?
Make the answer very short. 0.68. What is the ratio of the Value added (current US$) of Middle income in 2010 to that in 2011?
Your answer should be compact. 0.85. What is the ratio of the Value added (current US$) in North America in 2010 to that in 2011?
Your answer should be very brief. 0.82. What is the ratio of the Value added (current US$) of El Salvador in 2010 to that in 2011?
Offer a very short reply. 0.93. What is the ratio of the Value added (current US$) of Fiji in 2010 to that in 2011?
Provide a short and direct response. 0.85. What is the ratio of the Value added (current US$) in Middle income in 2010 to that in 2012?
Ensure brevity in your answer.  0.81. What is the ratio of the Value added (current US$) in North America in 2010 to that in 2012?
Give a very brief answer. 0.83. What is the ratio of the Value added (current US$) in El Salvador in 2010 to that in 2012?
Provide a short and direct response. 0.95. What is the ratio of the Value added (current US$) in Fiji in 2010 to that in 2012?
Keep it short and to the point. 0.77. What is the ratio of the Value added (current US$) in Middle income in 2010 to that in 2013?
Your response must be concise. 0.76. What is the ratio of the Value added (current US$) in North America in 2010 to that in 2013?
Your answer should be compact. 0.72. What is the ratio of the Value added (current US$) of El Salvador in 2010 to that in 2013?
Your response must be concise. 1.01. What is the ratio of the Value added (current US$) of Fiji in 2010 to that in 2013?
Your answer should be very brief. 0.7. What is the ratio of the Value added (current US$) of Middle income in 2011 to that in 2012?
Your answer should be compact. 0.95. What is the ratio of the Value added (current US$) of North America in 2011 to that in 2012?
Keep it short and to the point. 1.01. What is the ratio of the Value added (current US$) of El Salvador in 2011 to that in 2012?
Your answer should be very brief. 1.02. What is the ratio of the Value added (current US$) in Fiji in 2011 to that in 2012?
Make the answer very short. 0.91. What is the ratio of the Value added (current US$) of Middle income in 2011 to that in 2013?
Provide a short and direct response. 0.89. What is the ratio of the Value added (current US$) in North America in 2011 to that in 2013?
Offer a very short reply. 0.87. What is the ratio of the Value added (current US$) of El Salvador in 2011 to that in 2013?
Give a very brief answer. 1.08. What is the ratio of the Value added (current US$) in Fiji in 2011 to that in 2013?
Provide a succinct answer. 0.82. What is the ratio of the Value added (current US$) of Middle income in 2012 to that in 2013?
Keep it short and to the point. 0.94. What is the ratio of the Value added (current US$) in North America in 2012 to that in 2013?
Offer a very short reply. 0.86. What is the ratio of the Value added (current US$) in El Salvador in 2012 to that in 2013?
Your answer should be compact. 1.06. What is the ratio of the Value added (current US$) of Fiji in 2012 to that in 2013?
Keep it short and to the point. 0.91. What is the difference between the highest and the second highest Value added (current US$) in Middle income?
Offer a very short reply. 1.37e+11. What is the difference between the highest and the second highest Value added (current US$) of North America?
Offer a terse response. 3.31e+1. What is the difference between the highest and the second highest Value added (current US$) in El Salvador?
Offer a very short reply. 5.40e+07. What is the difference between the highest and the second highest Value added (current US$) in Fiji?
Provide a succinct answer. 2.23e+07. What is the difference between the highest and the lowest Value added (current US$) of Middle income?
Offer a terse response. 1.10e+12. What is the difference between the highest and the lowest Value added (current US$) of North America?
Provide a succinct answer. 9.73e+1. What is the difference between the highest and the lowest Value added (current US$) in El Salvador?
Your answer should be compact. 4.66e+08. What is the difference between the highest and the lowest Value added (current US$) of Fiji?
Provide a succinct answer. 1.34e+08. 